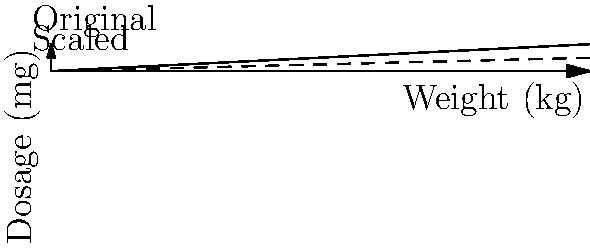A medication dosage chart shows a linear relationship between patient weight and medication dose. For a 100 kg patient, the dose is 5 mg. If you need to adjust the dosage for patients who weigh half as much, by what factor should you scale the original chart vertically to create a new chart for these lighter patients? To solve this problem, let's follow these steps:

1) The original chart shows a linear relationship between weight and dose. For a 100 kg patient, the dose is 5 mg.

2) We need to adjust for patients who weigh half as much. This means we're considering patients who weigh 50 kg.

3) In a linear relationship, if we halve the input (weight), we should also halve the output (dose).

4) So, for a 50 kg patient, the dose should be half of 5 mg, which is 2.5 mg.

5) To create a new chart for these lighter patients, we need to scale the original chart vertically so that it passes through the point (100, 2.5) instead of (100, 5).

6) The scaling factor is the ratio of the new y-coordinate to the original y-coordinate at x = 100:

   $\text{Scaling factor} = \frac{\text{New y}}{\text{Original y}} = \frac{2.5}{5} = 0.5$

Therefore, we need to scale the original chart vertically by a factor of 0.5, or in other words, reduce it to half its original height.
Answer: 0.5 